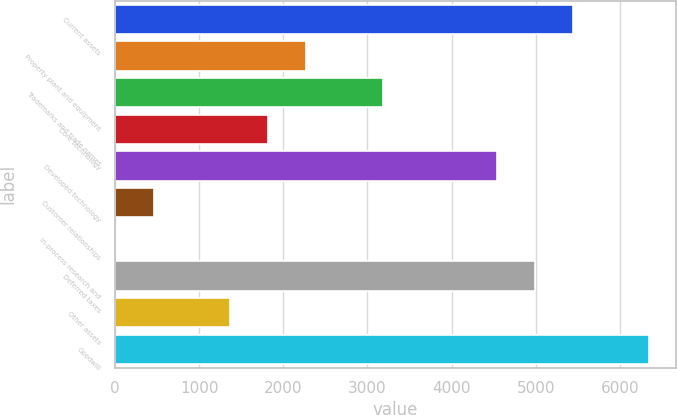Convert chart. <chart><loc_0><loc_0><loc_500><loc_500><bar_chart><fcel>Current assets<fcel>Property plant and equipment<fcel>Trademarks and trade names<fcel>Core technology<fcel>Developed technology<fcel>Customer relationships<fcel>In-process research and<fcel>Deferred taxes<fcel>Other assets<fcel>Goodwill<nl><fcel>5442.04<fcel>2274.05<fcel>3179.19<fcel>1821.48<fcel>4536.9<fcel>463.77<fcel>11.2<fcel>4989.47<fcel>1368.91<fcel>6347.18<nl></chart> 